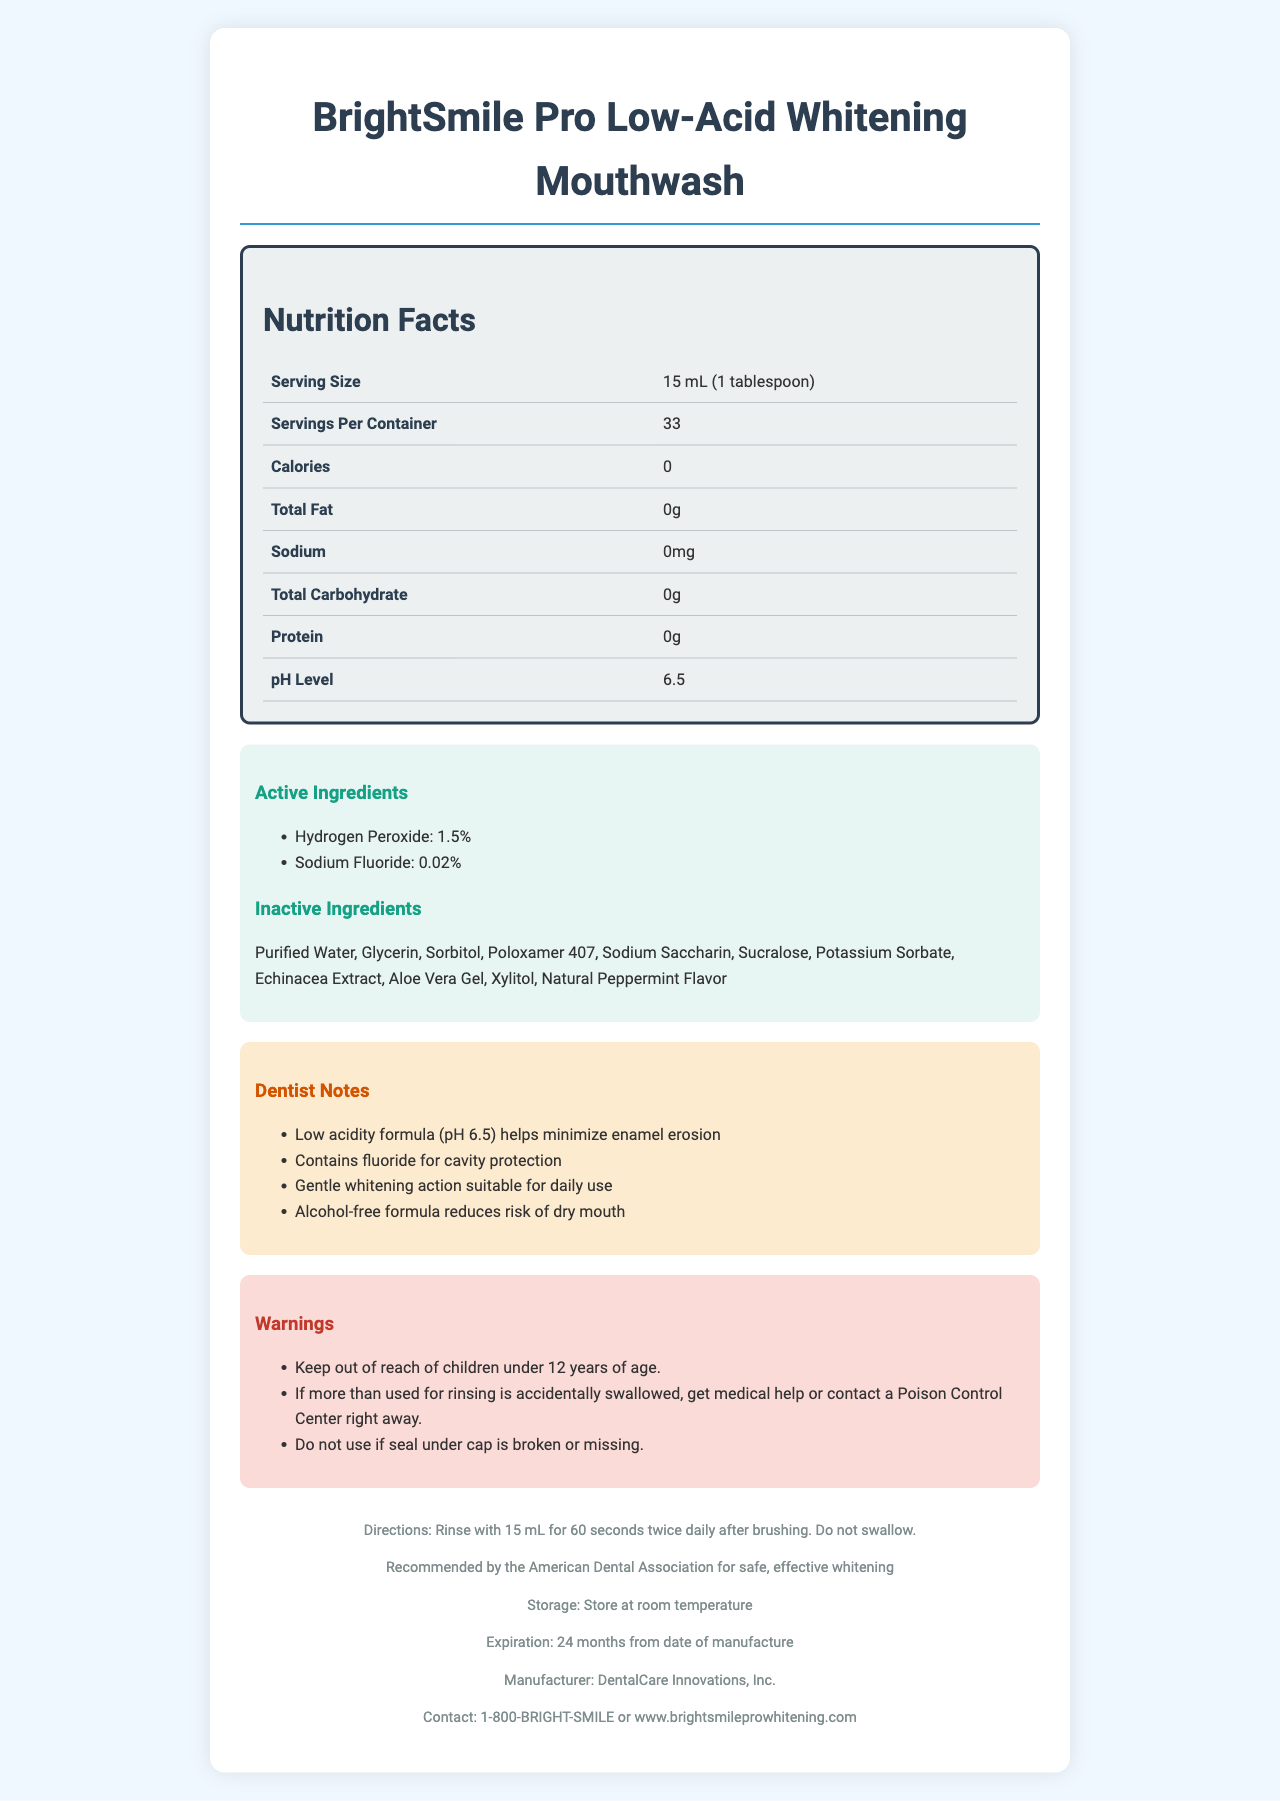what is the serving size of the mouthwash? The serving size is listed as 15 mL (1 tablespoon) in the nutrition facts.
Answer: 15 mL (1 tablespoon) How many servings are there per container? The nutrition facts section shows that there are 33 servings per container.
Answer: 33 What is the pH level of BrightSmile Pro Low-Acid Whitening Mouthwash? The pH level of the mouthwash is 6.5 as specified in the nutrition facts.
Answer: 6.5 What are the active ingredients of the mouthwash? Under the "Active Ingredients" section, Hydrogen Peroxide at 1.5% and Sodium Fluoride at 0.02% are listed.
Answer: Hydrogen Peroxide (1.5%), Sodium Fluoride (0.02%) What is the expiration period of this mouthwash from the date of manufacture? The footer section specifies that the expiration period is 24 months from the date of manufacture.
Answer: 24 months Which of the following is NOT an inactive ingredient in the mouthwash? A. Sorbitol B. Xylitol C. Benzoyl Peroxide Benzoyl Peroxide is not listed among the inactive ingredients; Sorbitol and Xylitol are.
Answer: C What is the calorie count per serving of this mouthwash? A. 5 B. 10 C. 0 D. 15 The nutrition facts indicate that the mouthwash has 0 calories per serving.
Answer: C Is the mouthwash alcohol-free? The dentist notes mention that this is an alcohol-free formula.
Answer: Yes Summarize the main points about BrightSmile Pro Low-Acid Whitening Mouthwash. This summary captures the primary details about the product, including its nutritional content, active ingredients, special properties, usage guidelines, and storage information.
Answer: BrightSmile Pro Low-Acid Whitening Mouthwash is designed to be a low-acidity formula with a pH level of 6.5 to minimize enamel erosion. It contains 0 calories and no fat, sodium, carbohydrates, or protein. The active ingredients are Hydrogen Peroxide (1.5%) for whitening and Sodium Fluoride (0.02%) for cavity protection. It's an alcohol-free formula and is recommended by the American Dental Association. It's suitable for daily use and provides gentle whitening. It should be stored at room temperature and expires 24 months from the date of manufacture. Who is the manufacturer of BrightSmile Pro Low-Acid Whitening Mouthwash? The footer section states that the manufacturer is DentalCare Innovations, Inc.
Answer: DentalCare Innovations, Inc. What should you do if you accidentally swallow more mouthwash than recommended? The warnings section advises getting medical help or contacting a Poison Control Center if more mouthwash is swallowed than recommended.
Answer: Get medical help or contact a Poison Control Center right away What is the suggested daily usage for this mouthwash? The directions section indicates that you should rinse with 15 mL for 60 seconds twice daily after brushing and not swallow.
Answer: Rinse with 15 mL for 60 seconds twice daily after brushing. Do not swallow. Why is the low acidity of this mouthwash beneficial? According to the dentist notes, the low acidity formula (pH 6.5) helps minimize enamel erosion.
Answer: It helps minimize enamel erosion How should the mouthwash be stored? The storage instructions in the footer say the mouthwash should be stored at room temperature.
Answer: At room temperature Does it contain any natural flavor? The ingredient list includes "Natural Peppermint Flavor," indicating that it contains natural flavor.
Answer: Yes What is the contact information provided for inquiries about BrightSmile Pro Low-Acid Whitening Mouthwash? The footer provides this contact information.
Answer: 1-800-BRIGHT-SMILE or www.brightsmileprowhitening.com Can you determine the retail price of the mouthwash from the document? The document does not provide any information regarding the retail price.
Answer: Not enough information What fluoride concentration does the mouthwash contain? The active ingredients section lists Sodium Fluoride at a concentration of 0.02%.
Answer: 0.02% 